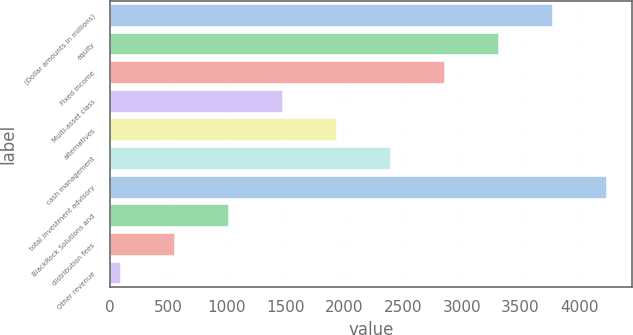<chart> <loc_0><loc_0><loc_500><loc_500><bar_chart><fcel>(Dollar amounts in millions)<fcel>equity<fcel>Fixed income<fcel>Multi-asset class<fcel>alternatives<fcel>cash management<fcel>total investment advisory<fcel>BlackRock Solutions and<fcel>distribution fees<fcel>Other revenue<nl><fcel>3779<fcel>3318.5<fcel>2858<fcel>1476.5<fcel>1937<fcel>2397.5<fcel>4239.5<fcel>1016<fcel>555.5<fcel>95<nl></chart> 